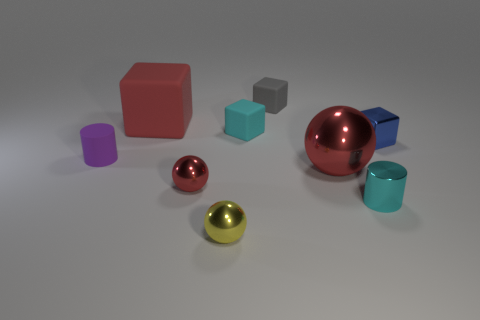Subtract 1 blocks. How many blocks are left? 3 Subtract all brown blocks. Subtract all gray spheres. How many blocks are left? 4 Add 1 small gray rubber blocks. How many objects exist? 10 Subtract all spheres. How many objects are left? 6 Add 5 cyan objects. How many cyan objects are left? 7 Add 1 tiny purple shiny balls. How many tiny purple shiny balls exist? 1 Subtract 1 cyan blocks. How many objects are left? 8 Subtract all red metal balls. Subtract all purple things. How many objects are left? 6 